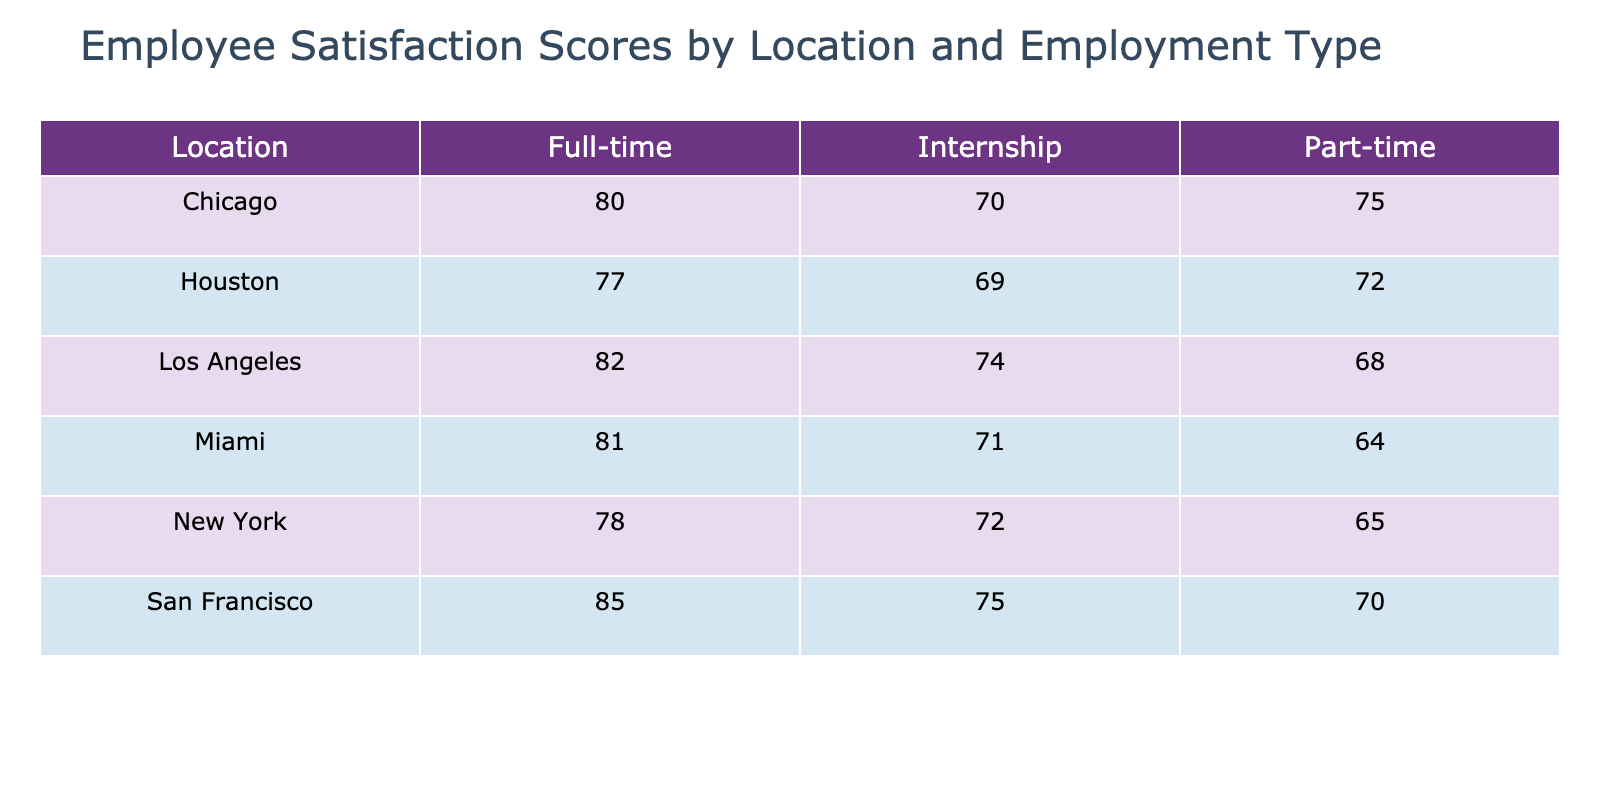What is the employee satisfaction score for Full-time employees in San Francisco? The table indicates that for San Francisco under Full-time employment, the Employee Satisfaction Score is 85.
Answer: 85 What is the average Employee Satisfaction Score for Part-time employees across all locations? To calculate the average, sum the scores for Part-time employees: (65 + 70 + 75 + 68 + 72 + 64) = 414. There are 6 locations, so the average is 414/6 = 69.
Answer: 69 Is the Employee Satisfaction Score for Interns in Chicago higher than that in New York? The table shows Chicago's Internship score is 70, while New York's is 72. Since 70 < 72, the statement is false.
Answer: No Which location has the highest employee satisfaction score for Part-time employees? Analyzing the scores for Part-time employees: New York (65), San Francisco (70), Chicago (75), Los Angeles (68), Houston (72), and Miami (64), the highest score is for Chicago at 75.
Answer: Chicago What is the difference between the average Employee Satisfaction Scores of Full-time employees in Los Angeles and Houston? First, identify the scores: Los Angeles has 82 and Houston has 77. The difference is 82 - 77 = 5.
Answer: 5 Which group (Full-time, Part-time, or Internship) has the lowest average satisfaction score across all locations? Calculate average scores for each group: Full-time = (78 + 85 + 80 + 82 + 77 + 81) / 6 = 80.3, Part-time = (65 + 70 + 75 + 68 + 72 + 64) / 6 = 69.7, Internship = (72 + 75 + 70 + 74 + 69 + 71) / 6 = 71.
Answer: Part-time Which location has the highest overall average Employee Satisfaction Score when considering all employment types? Calculate the overall average for each location: New York = (78 + 65 + 72) / 3 = 71.7, San Francisco = (85 + 70 + 75) / 3 = 76.7, Chicago = (80 + 75 + 70) / 3 = 75, Los Angeles = (82 + 68 + 74) / 3 = 74.7, Houston = (77 + 72 + 69) / 3 = 72.7, Miami = (81 + 64 + 71) / 3 = 72. The highest is San Francisco at 76.7.
Answer: San Francisco 